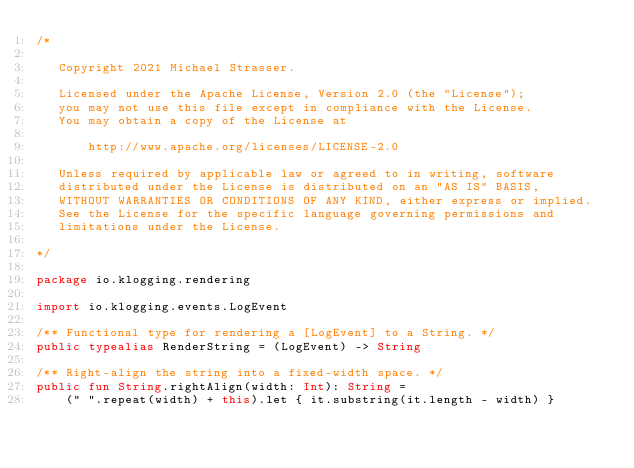Convert code to text. <code><loc_0><loc_0><loc_500><loc_500><_Kotlin_>/*

   Copyright 2021 Michael Strasser.

   Licensed under the Apache License, Version 2.0 (the "License");
   you may not use this file except in compliance with the License.
   You may obtain a copy of the License at

       http://www.apache.org/licenses/LICENSE-2.0

   Unless required by applicable law or agreed to in writing, software
   distributed under the License is distributed on an "AS IS" BASIS,
   WITHOUT WARRANTIES OR CONDITIONS OF ANY KIND, either express or implied.
   See the License for the specific language governing permissions and
   limitations under the License.

*/

package io.klogging.rendering

import io.klogging.events.LogEvent

/** Functional type for rendering a [LogEvent] to a String. */
public typealias RenderString = (LogEvent) -> String

/** Right-align the string into a fixed-width space. */
public fun String.rightAlign(width: Int): String =
    (" ".repeat(width) + this).let { it.substring(it.length - width) }
</code> 